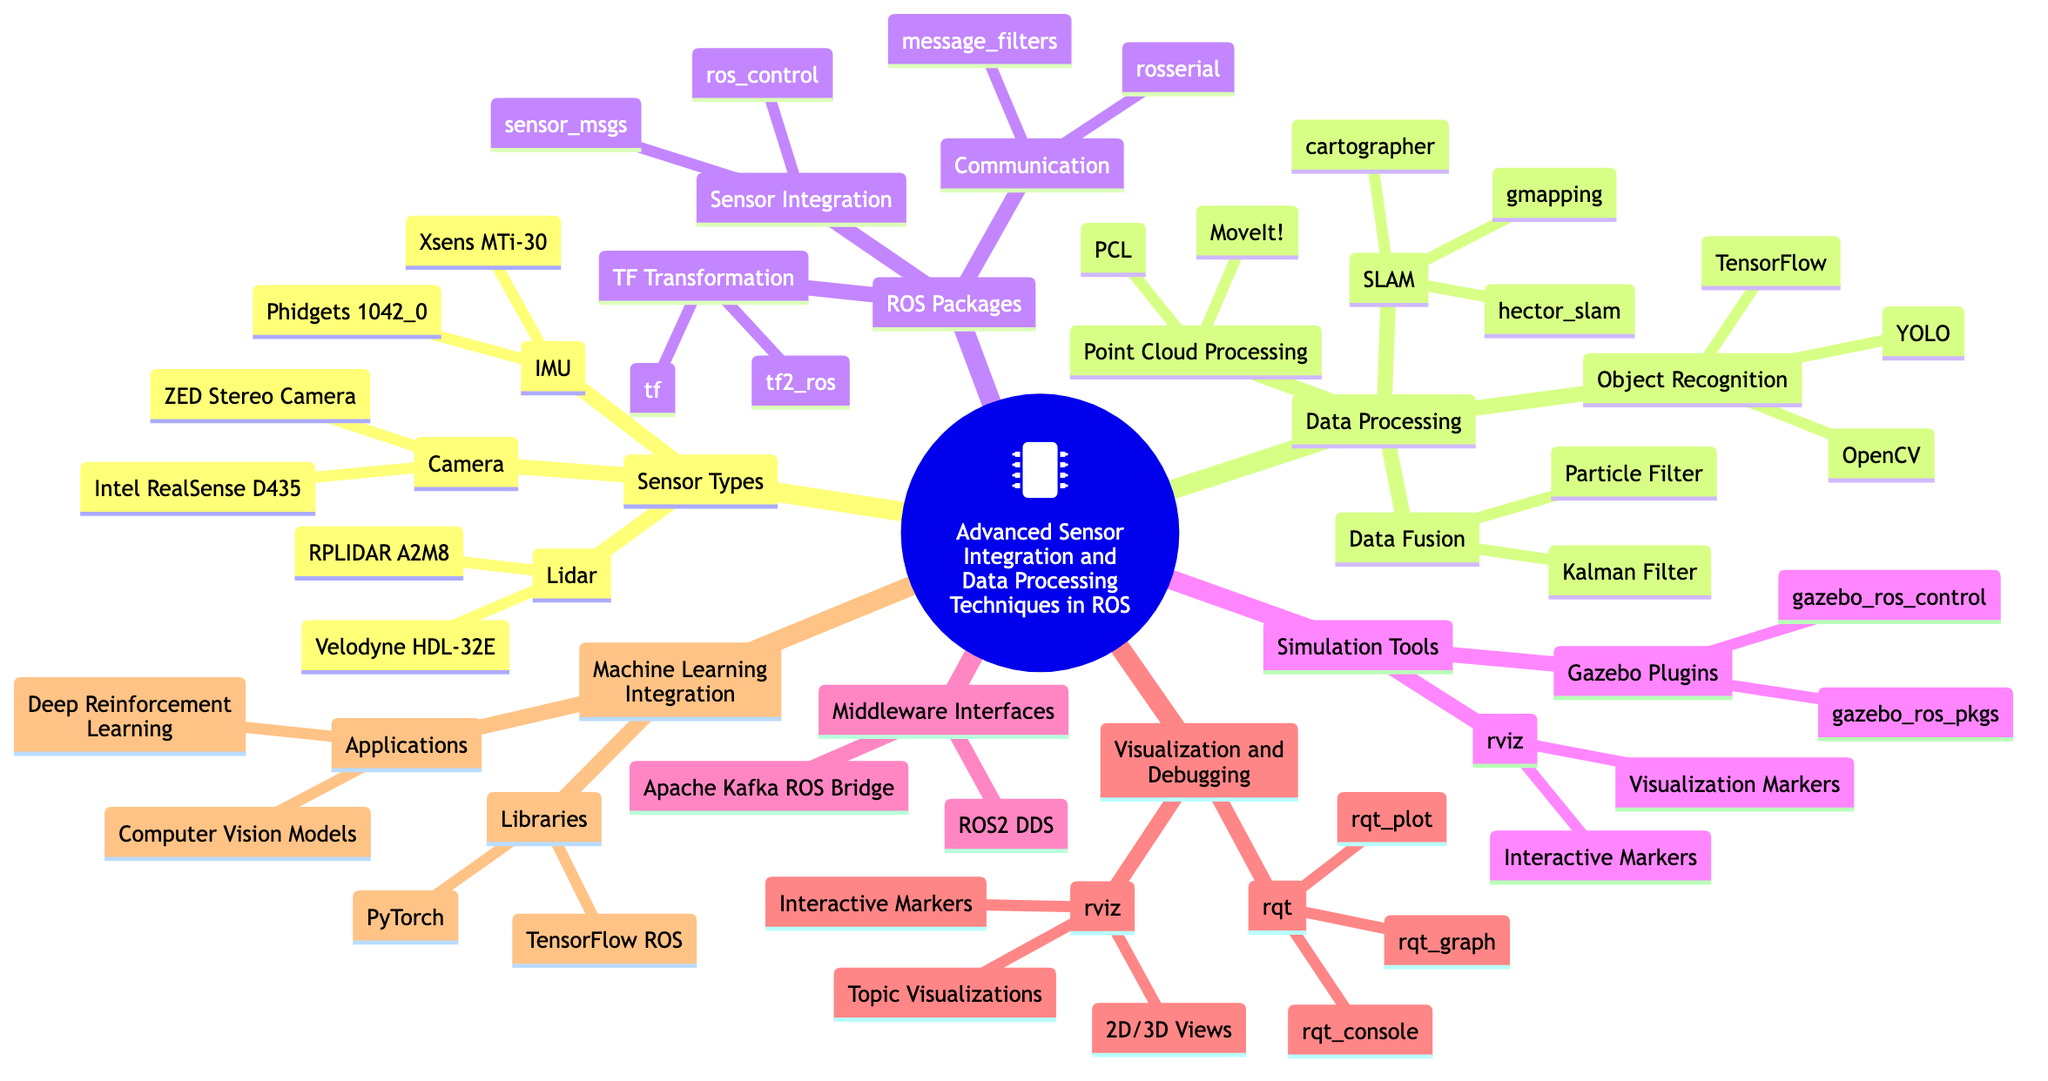What are two types of Lidar mentioned in the diagram? The diagram lists two types of Lidar under the "Sensor Types" section: Velodyne HDL-32E and RPLIDAR A2M8.
Answer: Velodyne HDL-32E, RPLIDAR A2M8 How many data processing techniques are listed under the "Data Processing" section? The "Data Processing" section includes four main categories: Data Fusion, SLAM, Object Recognition, and Point Cloud Processing. Each category contains various techniques. Thus, there are four main categories listed.
Answer: 4 Which ROS package is specifically for communication? Among the ROS Packages, the "Communication" category includes rosserial and message_filters, indicating that the answer pertains to that specific category, where "rosserial" is the name of one such package.
Answer: rosserial What is the middleware interface mentioned in the diagram? The diagram shows two middleware interfaces, but the specific question asks for one. ROS2 DDS is among those mentioned in the "Middleware Interfaces" section, so it fits the question perfectly.
Answer: ROS2 DDS Which tool is used for visualization and debugging in the diagram? The diagram lists rviz and rqt under the "Visualization and Debugging" section. The question does not specify which one, but rviz is commonly known for visualization, thus making it a suitable answer here.
Answer: rviz What is one library mentioned under Machine Learning Integration? The "Machine Learning Integration" section mentions TensorFlow ROS and PyTorch as libraries; therefore, either one can be used as the answer, but TensorFlow ROS is chosen for its wide recognition in the context.
Answer: TensorFlow ROS Which object recognition technique is included in the diagram? The "Object Recognition" category under "Data Processing" includes OpenCV, YOLO, and TensorFlow. Therefore, selecting one technique from the list gives a concise answer, and OpenCV is one of them.
Answer: OpenCV What are two Gazebo plugins listed in the diagram? In the "Simulation Tools" section under Gazebo Plugins, the diagram mentions gazebo_ros_control and gazebo_ros_pkgs. Asking for two plugins means that any two from this list suffice as an answer.
Answer: gazebo_ros_control, gazebo_ros_pkgs 